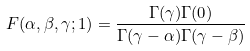<formula> <loc_0><loc_0><loc_500><loc_500>F ( \alpha , \beta , \gamma ; 1 ) = \frac { \Gamma ( \gamma ) \Gamma ( 0 ) } { \Gamma ( \gamma - \alpha ) \Gamma ( \gamma - \beta ) }</formula> 